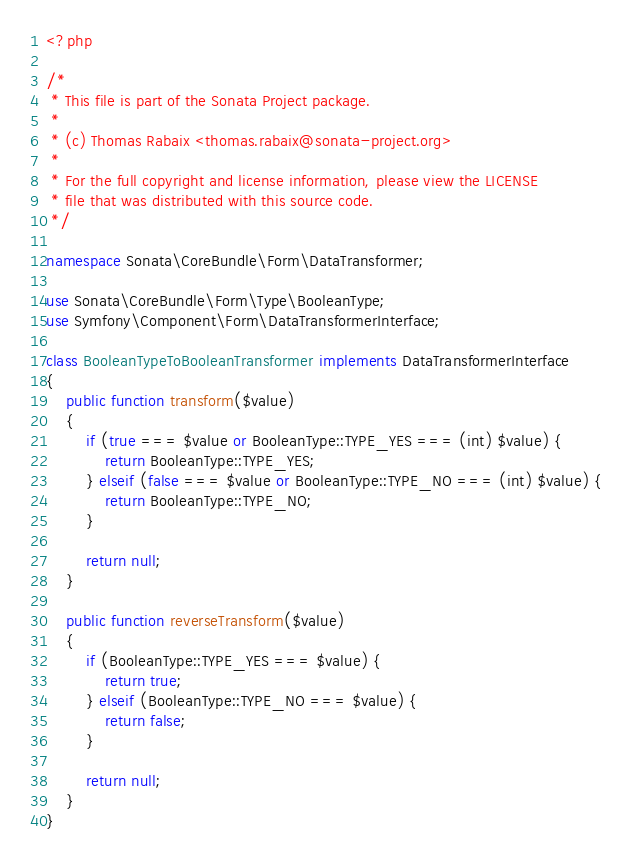Convert code to text. <code><loc_0><loc_0><loc_500><loc_500><_PHP_><?php

/*
 * This file is part of the Sonata Project package.
 *
 * (c) Thomas Rabaix <thomas.rabaix@sonata-project.org>
 *
 * For the full copyright and license information, please view the LICENSE
 * file that was distributed with this source code.
 */

namespace Sonata\CoreBundle\Form\DataTransformer;

use Sonata\CoreBundle\Form\Type\BooleanType;
use Symfony\Component\Form\DataTransformerInterface;

class BooleanTypeToBooleanTransformer implements DataTransformerInterface
{
    public function transform($value)
    {
        if (true === $value or BooleanType::TYPE_YES === (int) $value) {
            return BooleanType::TYPE_YES;
        } elseif (false === $value or BooleanType::TYPE_NO === (int) $value) {
            return BooleanType::TYPE_NO;
        }

        return null;
    }

    public function reverseTransform($value)
    {
        if (BooleanType::TYPE_YES === $value) {
            return true;
        } elseif (BooleanType::TYPE_NO === $value) {
            return false;
        }

        return null;
    }
}
</code> 